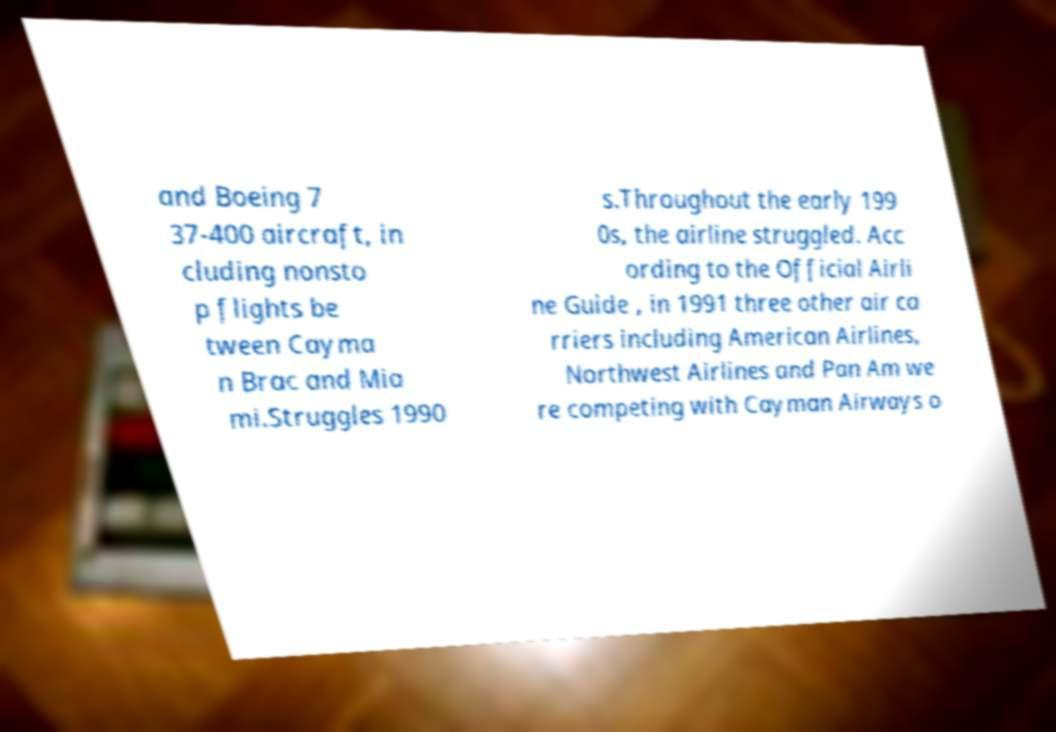Please read and relay the text visible in this image. What does it say? and Boeing 7 37-400 aircraft, in cluding nonsto p flights be tween Cayma n Brac and Mia mi.Struggles 1990 s.Throughout the early 199 0s, the airline struggled. Acc ording to the Official Airli ne Guide , in 1991 three other air ca rriers including American Airlines, Northwest Airlines and Pan Am we re competing with Cayman Airways o 